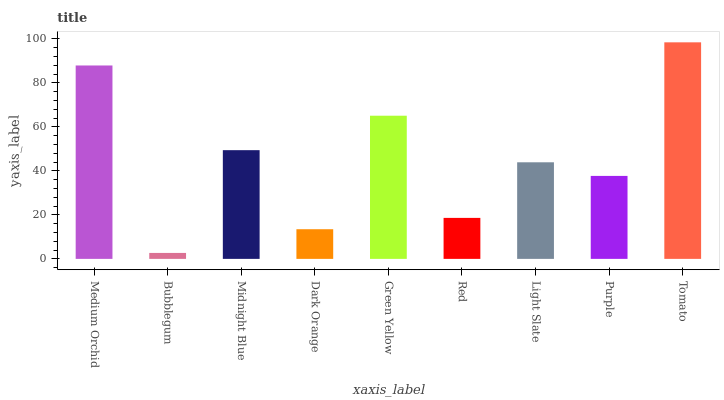Is Midnight Blue the minimum?
Answer yes or no. No. Is Midnight Blue the maximum?
Answer yes or no. No. Is Midnight Blue greater than Bubblegum?
Answer yes or no. Yes. Is Bubblegum less than Midnight Blue?
Answer yes or no. Yes. Is Bubblegum greater than Midnight Blue?
Answer yes or no. No. Is Midnight Blue less than Bubblegum?
Answer yes or no. No. Is Light Slate the high median?
Answer yes or no. Yes. Is Light Slate the low median?
Answer yes or no. Yes. Is Midnight Blue the high median?
Answer yes or no. No. Is Midnight Blue the low median?
Answer yes or no. No. 